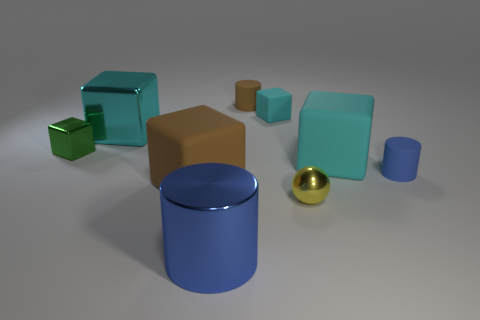Subtract all large rubber blocks. How many blocks are left? 3 Subtract all green cubes. How many blue cylinders are left? 2 Subtract all green blocks. How many blocks are left? 4 Subtract 1 cylinders. How many cylinders are left? 2 Add 1 cyan shiny cubes. How many objects exist? 10 Subtract all cubes. How many objects are left? 4 Subtract all matte cylinders. Subtract all large cyan rubber blocks. How many objects are left? 6 Add 4 yellow shiny spheres. How many yellow shiny spheres are left? 5 Add 4 green things. How many green things exist? 5 Subtract 0 cyan cylinders. How many objects are left? 9 